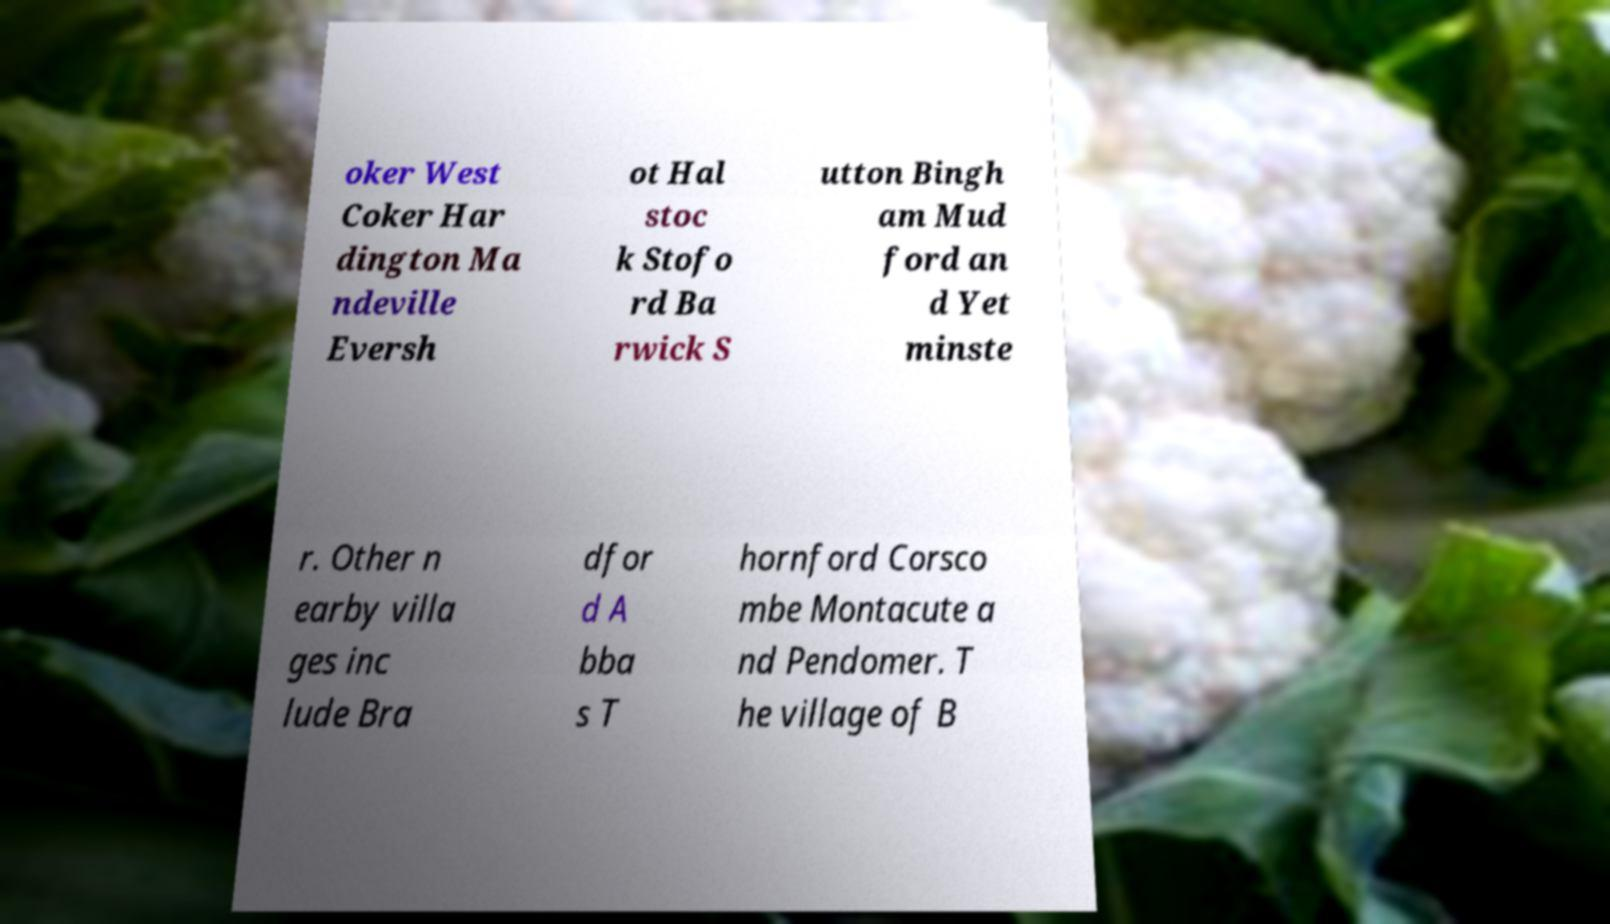There's text embedded in this image that I need extracted. Can you transcribe it verbatim? oker West Coker Har dington Ma ndeville Eversh ot Hal stoc k Stofo rd Ba rwick S utton Bingh am Mud ford an d Yet minste r. Other n earby villa ges inc lude Bra dfor d A bba s T hornford Corsco mbe Montacute a nd Pendomer. T he village of B 